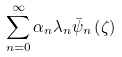<formula> <loc_0><loc_0><loc_500><loc_500>\sum _ { n = 0 } ^ { \infty } \alpha _ { n } \lambda _ { n } \bar { \psi } _ { n } \left ( \zeta \right )</formula> 